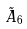<formula> <loc_0><loc_0><loc_500><loc_500>\tilde { A } _ { 6 }</formula> 